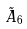<formula> <loc_0><loc_0><loc_500><loc_500>\tilde { A } _ { 6 }</formula> 